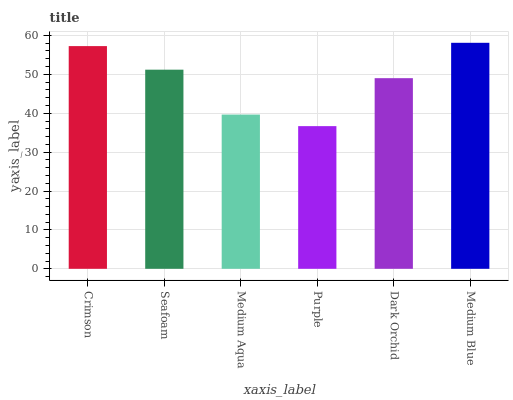Is Purple the minimum?
Answer yes or no. Yes. Is Medium Blue the maximum?
Answer yes or no. Yes. Is Seafoam the minimum?
Answer yes or no. No. Is Seafoam the maximum?
Answer yes or no. No. Is Crimson greater than Seafoam?
Answer yes or no. Yes. Is Seafoam less than Crimson?
Answer yes or no. Yes. Is Seafoam greater than Crimson?
Answer yes or no. No. Is Crimson less than Seafoam?
Answer yes or no. No. Is Seafoam the high median?
Answer yes or no. Yes. Is Dark Orchid the low median?
Answer yes or no. Yes. Is Crimson the high median?
Answer yes or no. No. Is Purple the low median?
Answer yes or no. No. 